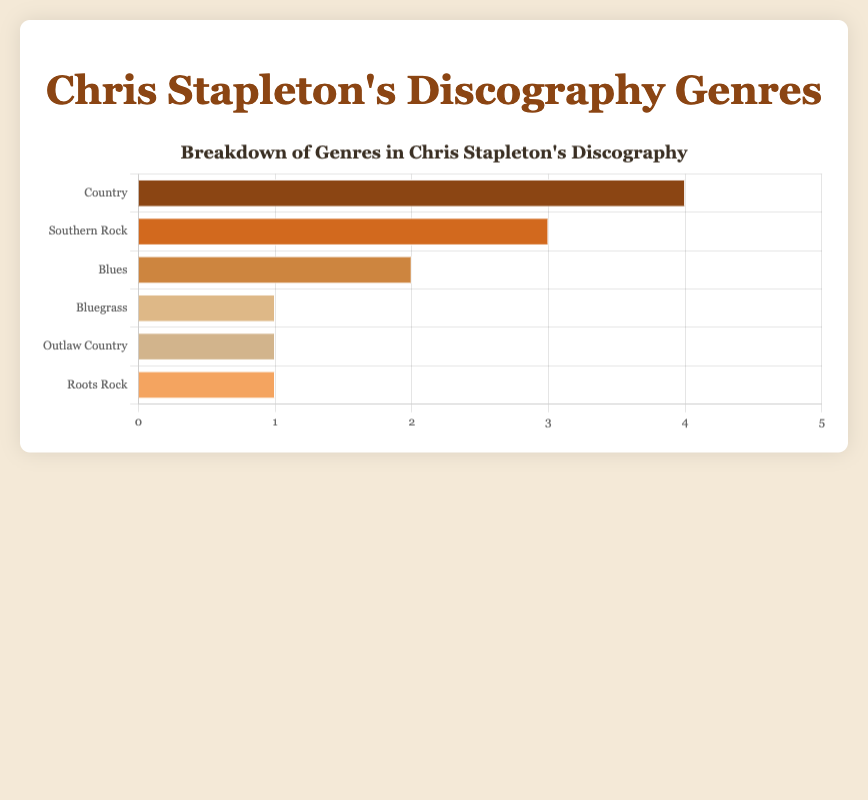Which genre does Chris Stapleton have the most albums in? By checking the lengths of the bars, we can see that 'Country' has the longest bar, indicating the highest number of albums. So, Chris Stapleton has the most albums in the 'Country' genre.
Answer: Country How many genres has Chris Stapleton released more than one album in? Identify the bars with lengths greater than one. There are three such genres: 'Country', 'Southern Rock', and 'Blues'.
Answer: 3 What is the total number of albums in genres other than Country? Sum the number of albums in all genres excluding Country: Southern Rock (3) + Blues (2) + Bluegrass (1) + Outlaw Country (1) + Roots Rock (1) = 8.
Answer: 8 Which genres have an equal number of albums? Look for bars of the same length. The genres 'Bluegrass', 'Outlaw Country', and 'Roots Rock' each have 1 album.
Answer: Bluegrass, Outlaw Country, and Roots Rock What's the ratio of Country albums to Southern Rock albums? Divide the number of Country albums by the number of Southern Rock albums: 4 / 3.
Answer: 4:3 What is the difference in the number of albums between 'Blues' and 'Bluegrass'? Subtract the number of albums in Bluegrass from the number in Blues: 2 - 1.
Answer: 1 How many albums does Chris Stapleton have in roots-related genres (combining Bluegrass, Roots Rock, and Southern Rock)? Sum the albums in Bluegrass (1), Roots Rock (1), and Southern Rock (3): 1 + 1 + 3 = 5.
Answer: 5 What colors are used to represent the genres with only one album? Identify the colors associated with 'Bluegrass', 'Outlaw Country', and 'Roots Rock' by their respective bars: beige, tan, and light tan.
Answer: beige, tan, and light tan What percentage of the total discography is made up by Country albums? Calculate the percentage by dividing the number of Country albums by the total number of albums, then multiply by 100: (4 / 12) * 100 = 33.3%.
Answer: 33.3% Which genre is represented by the darkest shade of brown in the bar chart? Look at the colors of the bars and identify which one has the darkest brown shade, associated with 'Country'.
Answer: Country 